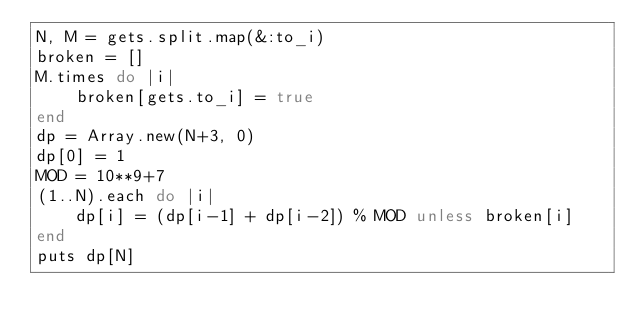<code> <loc_0><loc_0><loc_500><loc_500><_Ruby_>N, M = gets.split.map(&:to_i)
broken = []
M.times do |i|
    broken[gets.to_i] = true
end
dp = Array.new(N+3, 0)
dp[0] = 1
MOD = 10**9+7
(1..N).each do |i|
    dp[i] = (dp[i-1] + dp[i-2]) % MOD unless broken[i]
end
puts dp[N]</code> 